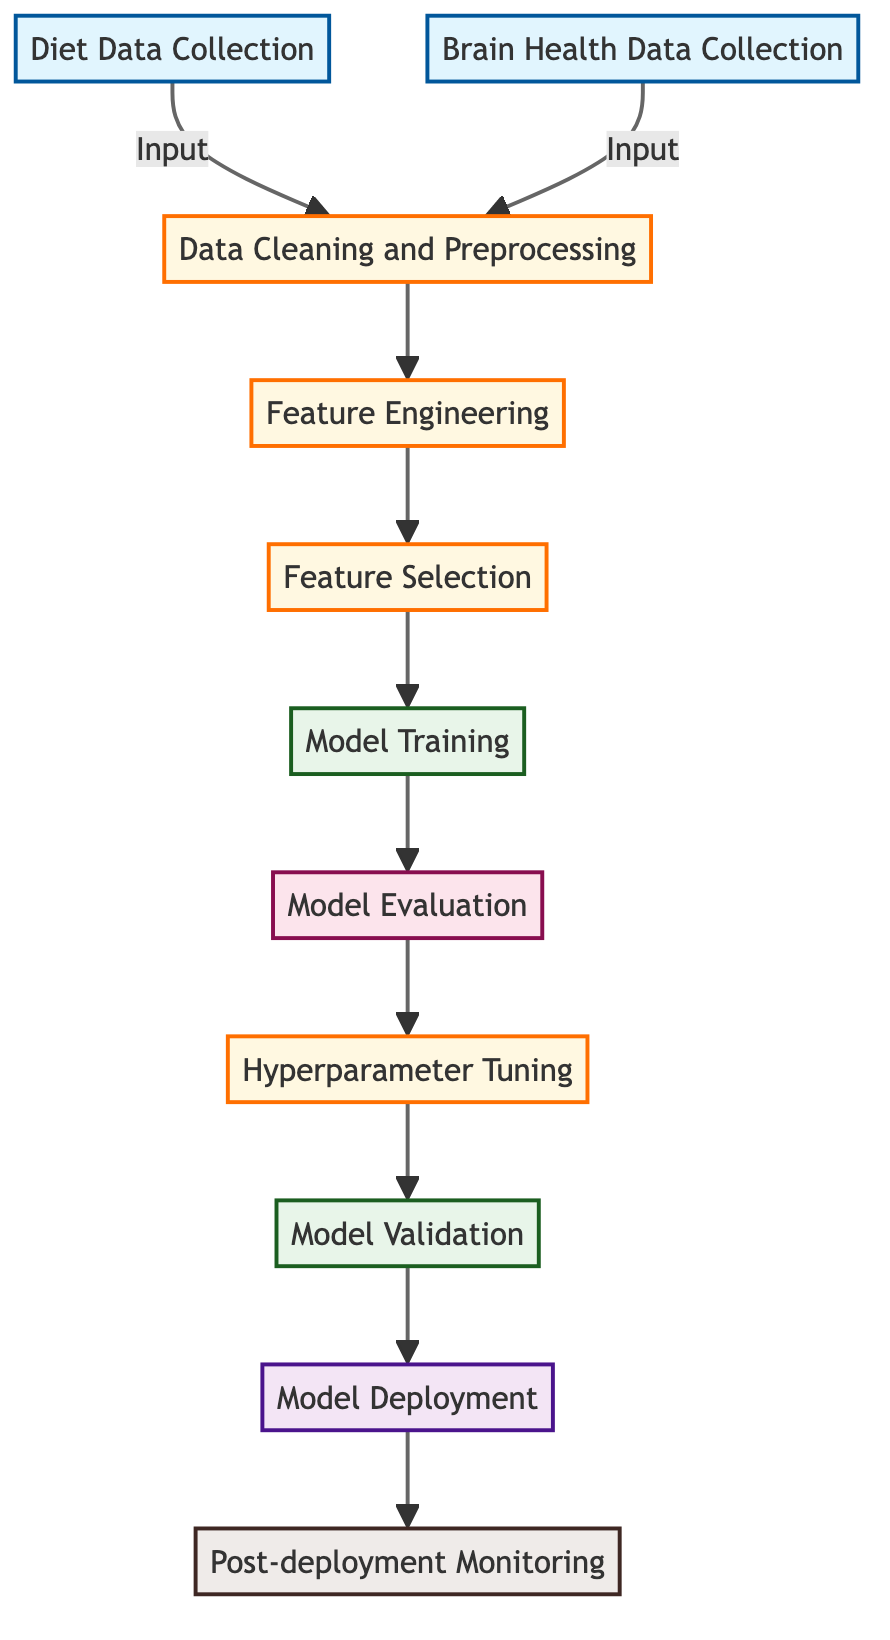What is the first step in the workflow? The first step in the workflow is "Diet Data Collection," which collects dietary intake data from participants.
Answer: Diet Data Collection How many data input nodes are present? There are two data input nodes: "Diet Data Collection" and "Brain Health Data Collection."
Answer: 2 What process follows "Data Cleaning and Preprocessing"? The process that follows "Data Cleaning and Preprocessing" is "Feature Engineering."
Answer: Feature Engineering Which nodes are classified as modeling? "Model Training," "Hyperparameter Tuning," and "Model Validation" are classified as modeling nodes.
Answer: Model Training, Hyperparameter Tuning, Model Validation What is the purpose of the "Model Evaluation" node? The purpose of the "Model Evaluation" node is to evaluate model performance using metrics like accuracy and precision.
Answer: Evaluate model performance What are the last two processes in the workflow? The last two processes in the workflow are "Model Deployment" and "Post-deployment Monitoring."
Answer: Model Deployment, Post-deployment Monitoring How does "Feature Selection" relate to "Feature Engineering"? "Feature Selection" follows "Feature Engineering," indicating it comes after generating relevant features from the data.
Answer: Follows What type of node is "Model Deployment"? "Model Deployment" is categorized as a deployment node, as indicated in the flowchart classification.
Answer: Deployment What is the outcome of the "Hyperparameter Tuning"? The outcome of "Hyperparameter Tuning" is to optimize model parameters to improve performance.
Answer: Optimize model parameters 